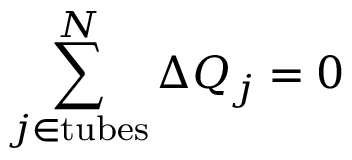Convert formula to latex. <formula><loc_0><loc_0><loc_500><loc_500>\sum _ { j \in { t u b e s } } ^ { N } \Delta Q _ { j } = 0</formula> 